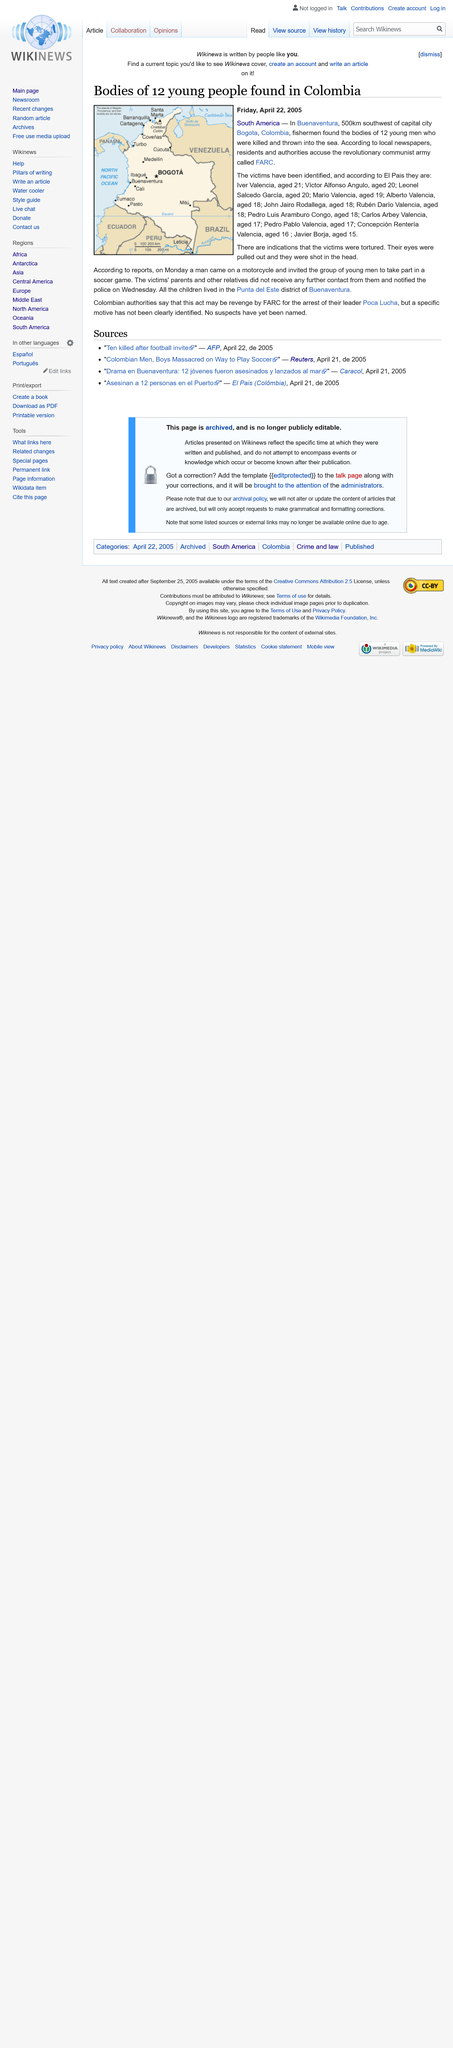Draw attention to some important aspects in this diagram. The victims were reportedly invited to play a soccer game, as stated in reports. Twelve young men were found dead in Columbia. The capital city of Colombia is Bogota. 